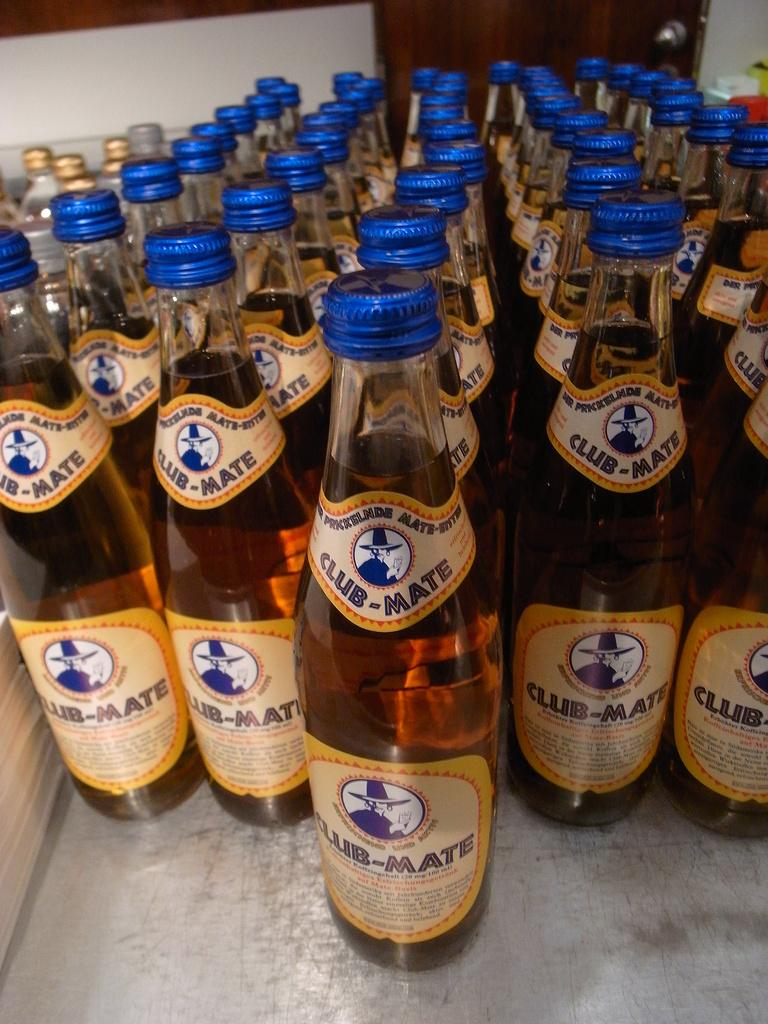<image>
Present a compact description of the photo's key features. Many bottles of beer, all of which have the label Club Mate. 